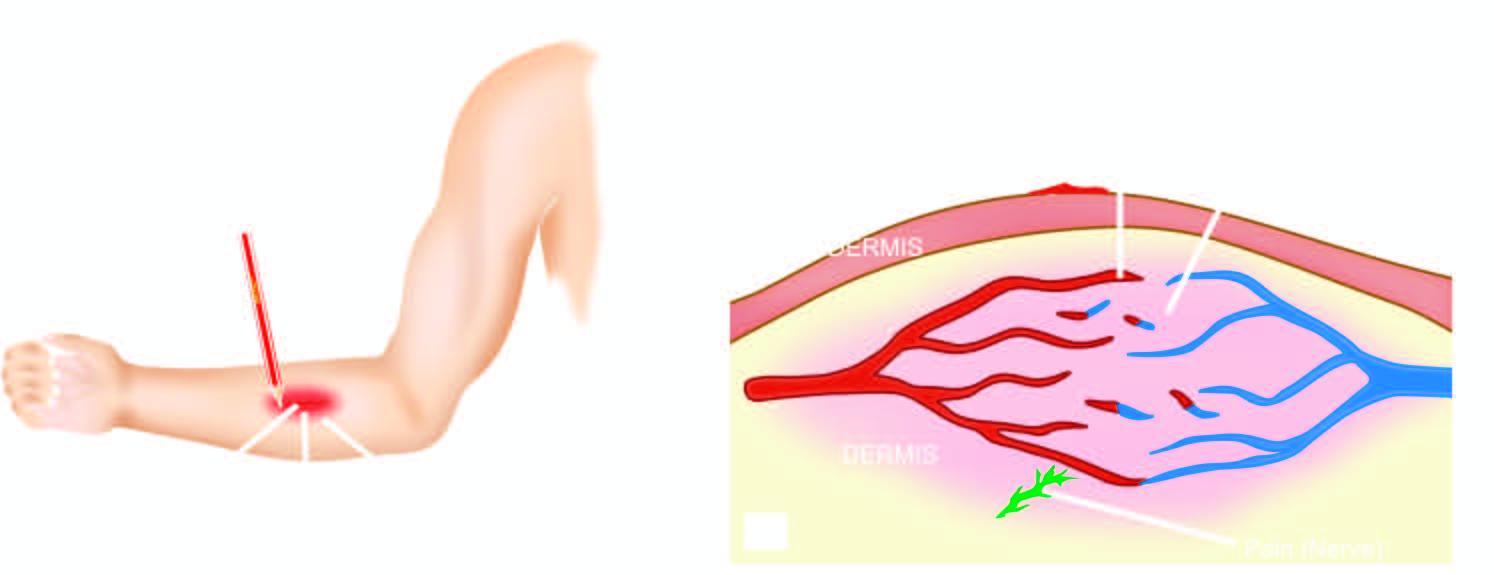what is elicited by firm stroking of skin of forearm with a pencil?
Answer the question using a single word or phrase. Triple response 